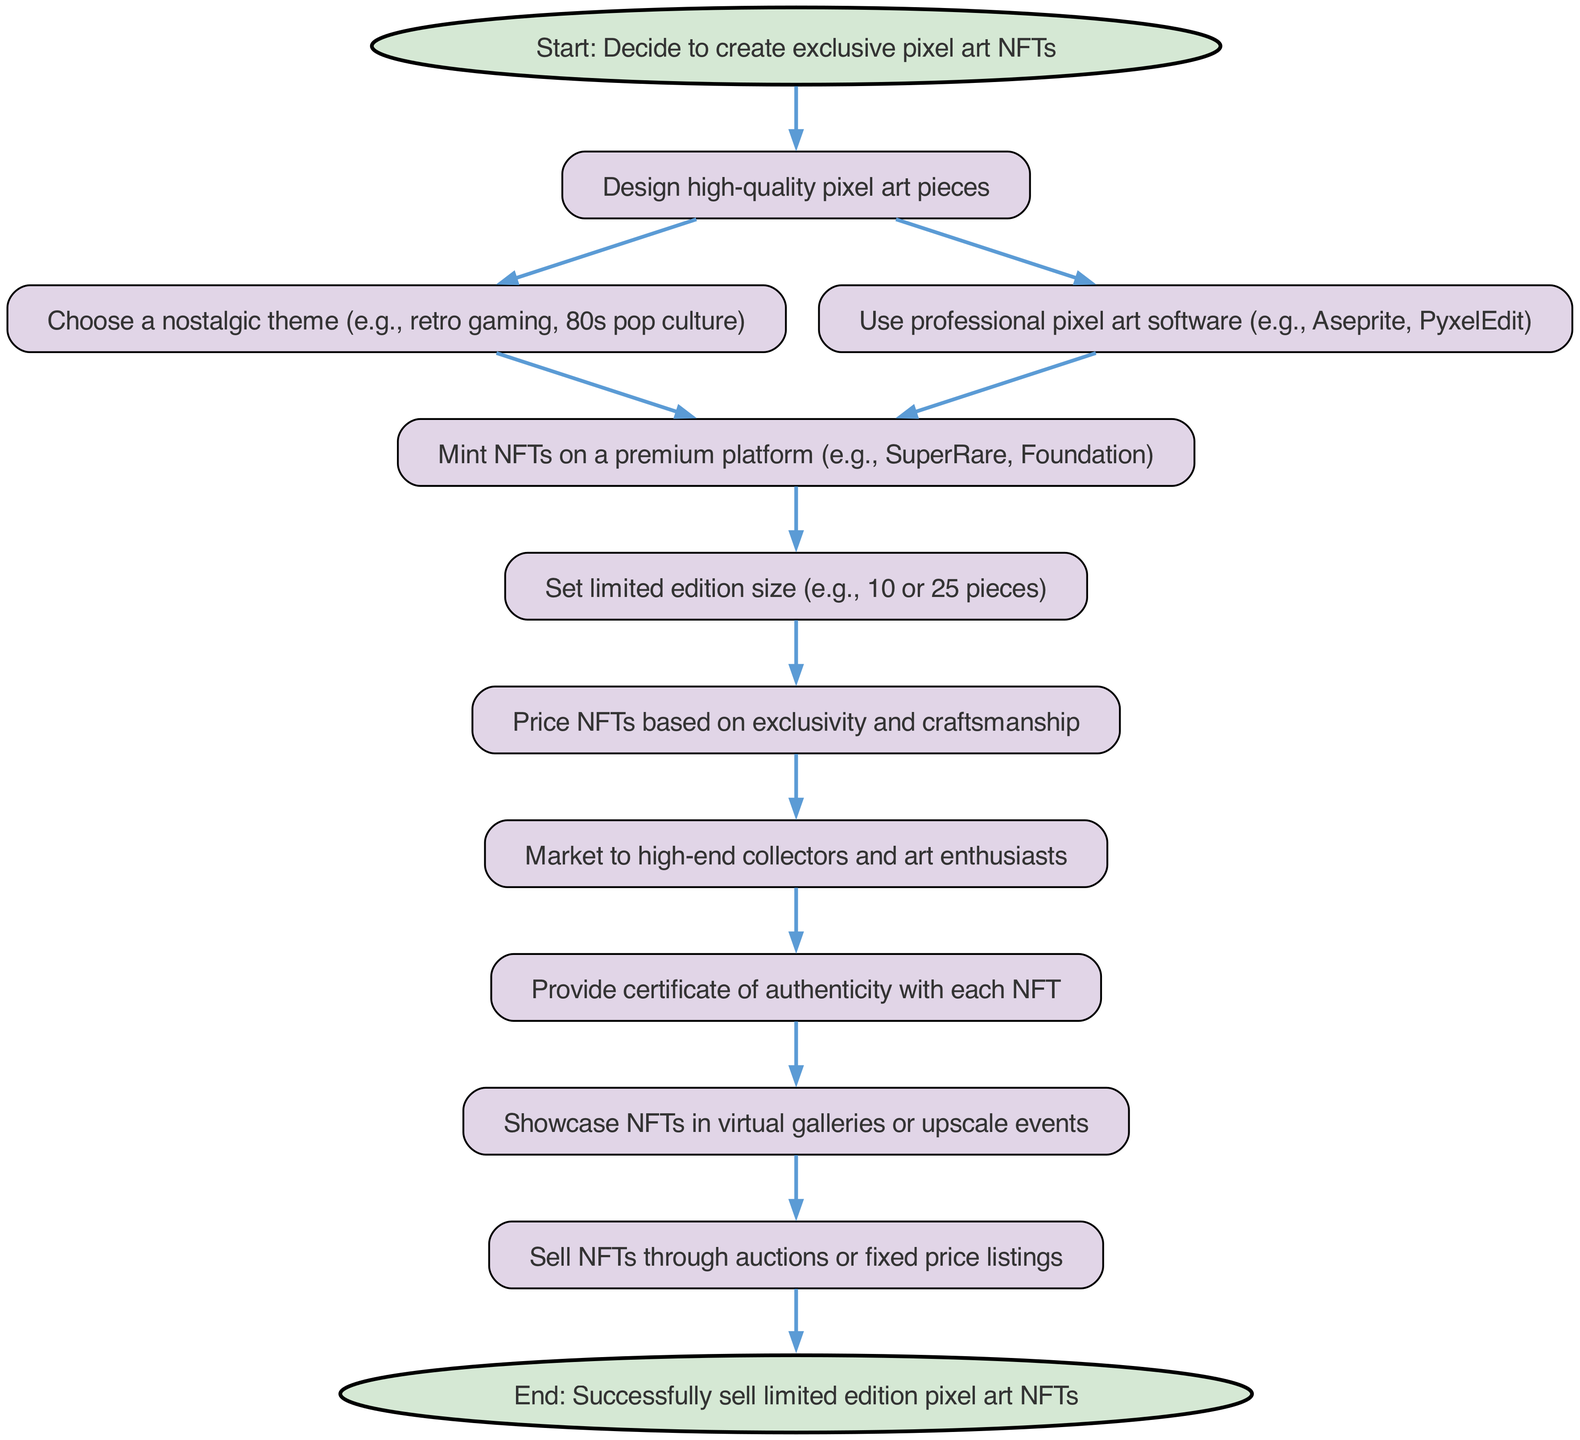What is the first step in the process? The first step is to "Decide to create exclusive pixel art NFTs," which is indicated as the starting point of the flowchart.
Answer: Start: Decide to create exclusive pixel art NFTs How many elements are in the diagram? By counting all unique nodes in the elements section, there are a total of 12 elements listed in the flowchart.
Answer: 12 What kind of software is suggested for creating pixel art? The diagram suggests using professional pixel art software, specifically mentioning "Aseprite" and "PyxelEdit."
Answer: Aseprite, PyxelEdit What is the relationship between setting limited edition size and pricing? After setting the limited edition size, the next step is to price the NFTs based on exclusivity and craftsmanship, indicating that pricing depends on how many pieces are available.
Answer: Pricing based on exclusivity What must be provided with each NFT? The diagram indicates that a "certificate of authenticity" must be provided with each NFT, which adds credibility and value to the artwork.
Answer: Certificate of authenticity Which node comes after showcasing NFTs? After "Showcase NFTs in virtual galleries or upscale events," the next step is "Sell NFTs through auctions or fixed price listings," indicating the final selling phase follows the exhibition.
Answer: Sell NFTs through auctions or fixed price listings Which theme is suggested for the pixel art designs? The flowchart suggests choosing a "nostalgic theme," specifically mentioning areas like retro gaming and 80s pop culture as examples of suitable themes.
Answer: Nostalgic theme (retro gaming, 80s pop culture) What is the purpose of marketing in the process? Marketing is aimed at high-end collectors and art enthusiasts, which is crucial for finding buyers who appreciate exclusive pixel art NFTs.
Answer: Market to high-end collectors and art enthusiasts What is the final step of the process? The final step in the flowchart is "End: Successfully sell limited edition pixel art NFTs," indicating the completion of the process.
Answer: End: Successfully sell limited edition pixel art NFTs 